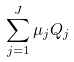<formula> <loc_0><loc_0><loc_500><loc_500>\sum _ { j = 1 } ^ { J } \mu _ { j } Q _ { j }</formula> 